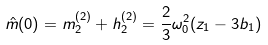Convert formula to latex. <formula><loc_0><loc_0><loc_500><loc_500>\hat { m } ( 0 ) = m _ { 2 } ^ { ( 2 ) } + h _ { 2 } ^ { ( 2 ) } = \frac { 2 } { 3 } \omega _ { 0 } ^ { 2 } ( z _ { 1 } - 3 b _ { 1 } )</formula> 